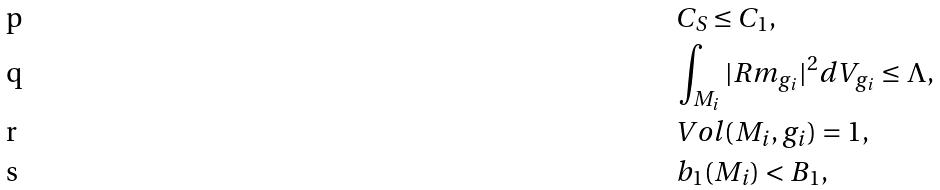Convert formula to latex. <formula><loc_0><loc_0><loc_500><loc_500>& C _ { S } \leq C _ { 1 } , \\ & \int _ { M _ { i } } | R m _ { g _ { i } } | ^ { 2 } d V _ { g _ { i } } \leq \Lambda , \\ & V o l ( M _ { i } , g _ { i } ) = 1 , \\ & b _ { 1 } ( M _ { i } ) < B _ { 1 } ,</formula> 